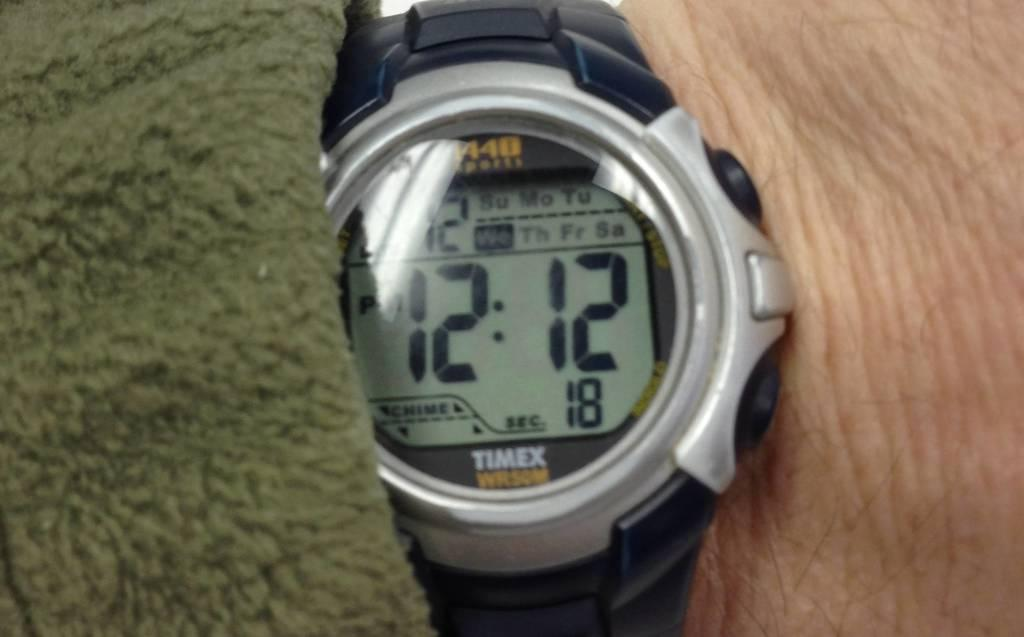Provide a one-sentence caption for the provided image. A wrist watch with a black band displaying the time of 12:12. 